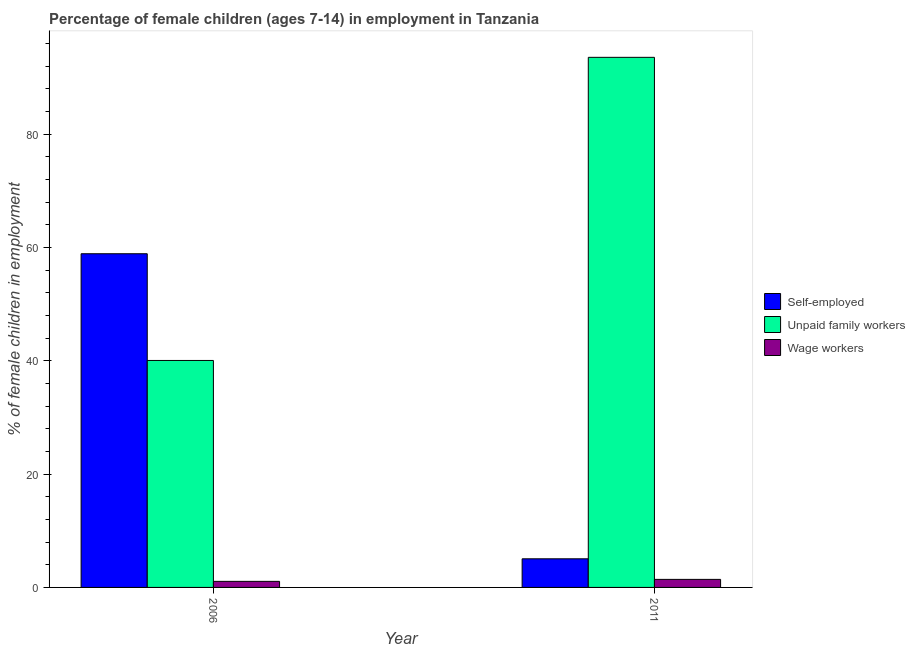How many different coloured bars are there?
Ensure brevity in your answer.  3. In how many cases, is the number of bars for a given year not equal to the number of legend labels?
Offer a terse response. 0. What is the percentage of children employed as unpaid family workers in 2011?
Keep it short and to the point. 93.54. Across all years, what is the maximum percentage of self employed children?
Provide a succinct answer. 58.88. Across all years, what is the minimum percentage of self employed children?
Keep it short and to the point. 5.05. In which year was the percentage of children employed as wage workers minimum?
Your answer should be compact. 2006. What is the total percentage of children employed as unpaid family workers in the graph?
Provide a succinct answer. 133.59. What is the difference between the percentage of self employed children in 2006 and that in 2011?
Give a very brief answer. 53.83. What is the difference between the percentage of children employed as wage workers in 2011 and the percentage of children employed as unpaid family workers in 2006?
Your response must be concise. 0.35. What is the average percentage of children employed as unpaid family workers per year?
Make the answer very short. 66.8. What is the ratio of the percentage of children employed as wage workers in 2006 to that in 2011?
Your answer should be compact. 0.75. In how many years, is the percentage of self employed children greater than the average percentage of self employed children taken over all years?
Give a very brief answer. 1. What does the 3rd bar from the left in 2011 represents?
Ensure brevity in your answer.  Wage workers. What does the 1st bar from the right in 2006 represents?
Ensure brevity in your answer.  Wage workers. Is it the case that in every year, the sum of the percentage of self employed children and percentage of children employed as unpaid family workers is greater than the percentage of children employed as wage workers?
Offer a terse response. Yes. Are all the bars in the graph horizontal?
Provide a short and direct response. No. How many years are there in the graph?
Offer a terse response. 2. Are the values on the major ticks of Y-axis written in scientific E-notation?
Provide a succinct answer. No. Does the graph contain grids?
Provide a short and direct response. No. Where does the legend appear in the graph?
Offer a terse response. Center right. How many legend labels are there?
Provide a succinct answer. 3. What is the title of the graph?
Ensure brevity in your answer.  Percentage of female children (ages 7-14) in employment in Tanzania. Does "New Zealand" appear as one of the legend labels in the graph?
Offer a very short reply. No. What is the label or title of the X-axis?
Make the answer very short. Year. What is the label or title of the Y-axis?
Your answer should be very brief. % of female children in employment. What is the % of female children in employment in Self-employed in 2006?
Your response must be concise. 58.88. What is the % of female children in employment in Unpaid family workers in 2006?
Your answer should be compact. 40.05. What is the % of female children in employment in Wage workers in 2006?
Offer a terse response. 1.07. What is the % of female children in employment of Self-employed in 2011?
Provide a short and direct response. 5.05. What is the % of female children in employment in Unpaid family workers in 2011?
Your answer should be very brief. 93.54. What is the % of female children in employment of Wage workers in 2011?
Offer a terse response. 1.42. Across all years, what is the maximum % of female children in employment of Self-employed?
Give a very brief answer. 58.88. Across all years, what is the maximum % of female children in employment in Unpaid family workers?
Your response must be concise. 93.54. Across all years, what is the maximum % of female children in employment in Wage workers?
Your answer should be very brief. 1.42. Across all years, what is the minimum % of female children in employment in Self-employed?
Your answer should be very brief. 5.05. Across all years, what is the minimum % of female children in employment in Unpaid family workers?
Provide a short and direct response. 40.05. Across all years, what is the minimum % of female children in employment of Wage workers?
Ensure brevity in your answer.  1.07. What is the total % of female children in employment in Self-employed in the graph?
Keep it short and to the point. 63.93. What is the total % of female children in employment in Unpaid family workers in the graph?
Ensure brevity in your answer.  133.59. What is the total % of female children in employment of Wage workers in the graph?
Ensure brevity in your answer.  2.49. What is the difference between the % of female children in employment of Self-employed in 2006 and that in 2011?
Your answer should be very brief. 53.83. What is the difference between the % of female children in employment in Unpaid family workers in 2006 and that in 2011?
Make the answer very short. -53.49. What is the difference between the % of female children in employment in Wage workers in 2006 and that in 2011?
Keep it short and to the point. -0.35. What is the difference between the % of female children in employment in Self-employed in 2006 and the % of female children in employment in Unpaid family workers in 2011?
Ensure brevity in your answer.  -34.66. What is the difference between the % of female children in employment of Self-employed in 2006 and the % of female children in employment of Wage workers in 2011?
Your answer should be compact. 57.46. What is the difference between the % of female children in employment of Unpaid family workers in 2006 and the % of female children in employment of Wage workers in 2011?
Provide a succinct answer. 38.63. What is the average % of female children in employment of Self-employed per year?
Provide a succinct answer. 31.96. What is the average % of female children in employment in Unpaid family workers per year?
Provide a succinct answer. 66.8. What is the average % of female children in employment of Wage workers per year?
Offer a very short reply. 1.25. In the year 2006, what is the difference between the % of female children in employment in Self-employed and % of female children in employment in Unpaid family workers?
Keep it short and to the point. 18.83. In the year 2006, what is the difference between the % of female children in employment of Self-employed and % of female children in employment of Wage workers?
Your answer should be compact. 57.81. In the year 2006, what is the difference between the % of female children in employment in Unpaid family workers and % of female children in employment in Wage workers?
Offer a very short reply. 38.98. In the year 2011, what is the difference between the % of female children in employment of Self-employed and % of female children in employment of Unpaid family workers?
Your answer should be very brief. -88.49. In the year 2011, what is the difference between the % of female children in employment in Self-employed and % of female children in employment in Wage workers?
Ensure brevity in your answer.  3.63. In the year 2011, what is the difference between the % of female children in employment of Unpaid family workers and % of female children in employment of Wage workers?
Your answer should be very brief. 92.12. What is the ratio of the % of female children in employment in Self-employed in 2006 to that in 2011?
Ensure brevity in your answer.  11.66. What is the ratio of the % of female children in employment of Unpaid family workers in 2006 to that in 2011?
Your answer should be very brief. 0.43. What is the ratio of the % of female children in employment of Wage workers in 2006 to that in 2011?
Ensure brevity in your answer.  0.75. What is the difference between the highest and the second highest % of female children in employment in Self-employed?
Your answer should be very brief. 53.83. What is the difference between the highest and the second highest % of female children in employment in Unpaid family workers?
Your answer should be very brief. 53.49. What is the difference between the highest and the lowest % of female children in employment in Self-employed?
Make the answer very short. 53.83. What is the difference between the highest and the lowest % of female children in employment in Unpaid family workers?
Keep it short and to the point. 53.49. What is the difference between the highest and the lowest % of female children in employment of Wage workers?
Your answer should be very brief. 0.35. 